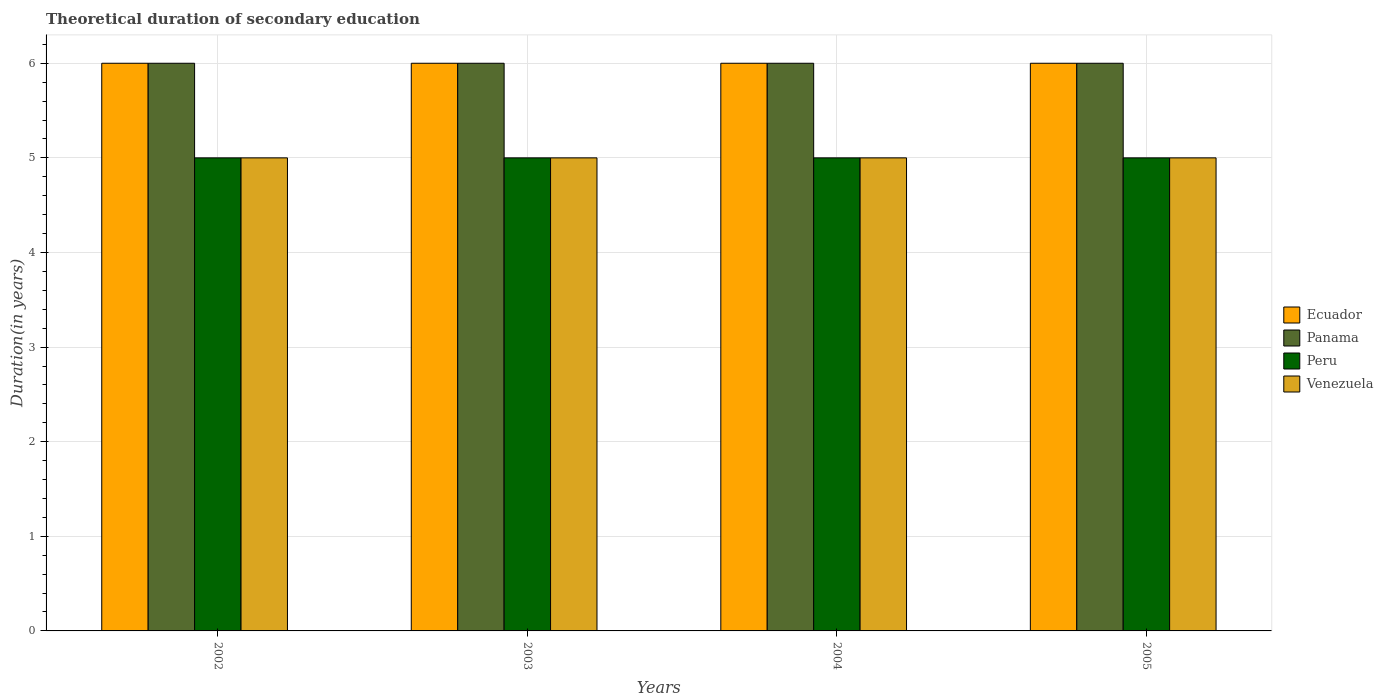How many different coloured bars are there?
Keep it short and to the point. 4. How many groups of bars are there?
Offer a very short reply. 4. How many bars are there on the 2nd tick from the right?
Your response must be concise. 4. In how many cases, is the number of bars for a given year not equal to the number of legend labels?
Your answer should be compact. 0. What is the total theoretical duration of secondary education in Peru in 2003?
Your response must be concise. 5. Across all years, what is the maximum total theoretical duration of secondary education in Ecuador?
Provide a short and direct response. 6. Across all years, what is the minimum total theoretical duration of secondary education in Ecuador?
Keep it short and to the point. 6. In which year was the total theoretical duration of secondary education in Venezuela maximum?
Offer a very short reply. 2002. In which year was the total theoretical duration of secondary education in Peru minimum?
Your response must be concise. 2002. What is the total total theoretical duration of secondary education in Peru in the graph?
Make the answer very short. 20. In the year 2005, what is the difference between the total theoretical duration of secondary education in Peru and total theoretical duration of secondary education in Ecuador?
Offer a very short reply. -1. In how many years, is the total theoretical duration of secondary education in Panama greater than 4.2 years?
Offer a terse response. 4. What is the difference between the highest and the lowest total theoretical duration of secondary education in Venezuela?
Provide a succinct answer. 0. Is the sum of the total theoretical duration of secondary education in Peru in 2002 and 2005 greater than the maximum total theoretical duration of secondary education in Venezuela across all years?
Offer a terse response. Yes. Is it the case that in every year, the sum of the total theoretical duration of secondary education in Panama and total theoretical duration of secondary education in Venezuela is greater than the sum of total theoretical duration of secondary education in Peru and total theoretical duration of secondary education in Ecuador?
Your response must be concise. No. What does the 1st bar from the left in 2005 represents?
Provide a short and direct response. Ecuador. What does the 3rd bar from the right in 2002 represents?
Keep it short and to the point. Panama. Is it the case that in every year, the sum of the total theoretical duration of secondary education in Peru and total theoretical duration of secondary education in Panama is greater than the total theoretical duration of secondary education in Ecuador?
Your response must be concise. Yes. How many bars are there?
Ensure brevity in your answer.  16. Are all the bars in the graph horizontal?
Your answer should be compact. No. How many years are there in the graph?
Make the answer very short. 4. What is the difference between two consecutive major ticks on the Y-axis?
Your answer should be very brief. 1. Are the values on the major ticks of Y-axis written in scientific E-notation?
Ensure brevity in your answer.  No. How are the legend labels stacked?
Keep it short and to the point. Vertical. What is the title of the graph?
Give a very brief answer. Theoretical duration of secondary education. Does "Australia" appear as one of the legend labels in the graph?
Provide a short and direct response. No. What is the label or title of the X-axis?
Give a very brief answer. Years. What is the label or title of the Y-axis?
Your answer should be compact. Duration(in years). What is the Duration(in years) of Peru in 2002?
Your answer should be compact. 5. What is the Duration(in years) of Ecuador in 2003?
Provide a succinct answer. 6. What is the Duration(in years) in Panama in 2003?
Your answer should be very brief. 6. What is the Duration(in years) in Peru in 2003?
Your answer should be very brief. 5. What is the Duration(in years) in Peru in 2004?
Offer a terse response. 5. What is the Duration(in years) of Venezuela in 2004?
Your response must be concise. 5. What is the Duration(in years) in Peru in 2005?
Offer a very short reply. 5. What is the Duration(in years) in Venezuela in 2005?
Provide a short and direct response. 5. Across all years, what is the maximum Duration(in years) of Peru?
Make the answer very short. 5. Across all years, what is the maximum Duration(in years) of Venezuela?
Provide a succinct answer. 5. Across all years, what is the minimum Duration(in years) of Ecuador?
Provide a succinct answer. 6. Across all years, what is the minimum Duration(in years) of Panama?
Offer a very short reply. 6. Across all years, what is the minimum Duration(in years) of Peru?
Your answer should be very brief. 5. Across all years, what is the minimum Duration(in years) of Venezuela?
Your answer should be compact. 5. What is the difference between the Duration(in years) in Ecuador in 2002 and that in 2003?
Offer a terse response. 0. What is the difference between the Duration(in years) of Peru in 2002 and that in 2003?
Ensure brevity in your answer.  0. What is the difference between the Duration(in years) of Venezuela in 2002 and that in 2004?
Ensure brevity in your answer.  0. What is the difference between the Duration(in years) of Panama in 2002 and that in 2005?
Your response must be concise. 0. What is the difference between the Duration(in years) in Peru in 2002 and that in 2005?
Give a very brief answer. 0. What is the difference between the Duration(in years) of Peru in 2003 and that in 2004?
Keep it short and to the point. 0. What is the difference between the Duration(in years) of Panama in 2003 and that in 2005?
Offer a terse response. 0. What is the difference between the Duration(in years) in Peru in 2003 and that in 2005?
Give a very brief answer. 0. What is the difference between the Duration(in years) in Panama in 2004 and that in 2005?
Give a very brief answer. 0. What is the difference between the Duration(in years) in Venezuela in 2004 and that in 2005?
Make the answer very short. 0. What is the difference between the Duration(in years) of Ecuador in 2002 and the Duration(in years) of Panama in 2003?
Provide a succinct answer. 0. What is the difference between the Duration(in years) in Ecuador in 2002 and the Duration(in years) in Peru in 2003?
Your answer should be compact. 1. What is the difference between the Duration(in years) of Ecuador in 2002 and the Duration(in years) of Venezuela in 2003?
Provide a succinct answer. 1. What is the difference between the Duration(in years) of Panama in 2002 and the Duration(in years) of Peru in 2003?
Your answer should be very brief. 1. What is the difference between the Duration(in years) of Panama in 2002 and the Duration(in years) of Venezuela in 2003?
Your answer should be very brief. 1. What is the difference between the Duration(in years) of Peru in 2002 and the Duration(in years) of Venezuela in 2003?
Make the answer very short. 0. What is the difference between the Duration(in years) in Ecuador in 2002 and the Duration(in years) in Panama in 2004?
Your response must be concise. 0. What is the difference between the Duration(in years) in Ecuador in 2002 and the Duration(in years) in Peru in 2004?
Your answer should be compact. 1. What is the difference between the Duration(in years) in Panama in 2002 and the Duration(in years) in Peru in 2004?
Your answer should be very brief. 1. What is the difference between the Duration(in years) of Panama in 2002 and the Duration(in years) of Peru in 2005?
Your answer should be compact. 1. What is the difference between the Duration(in years) of Panama in 2002 and the Duration(in years) of Venezuela in 2005?
Offer a very short reply. 1. What is the difference between the Duration(in years) in Peru in 2002 and the Duration(in years) in Venezuela in 2005?
Keep it short and to the point. 0. What is the difference between the Duration(in years) of Ecuador in 2003 and the Duration(in years) of Panama in 2004?
Your answer should be compact. 0. What is the difference between the Duration(in years) in Ecuador in 2003 and the Duration(in years) in Peru in 2004?
Your answer should be very brief. 1. What is the difference between the Duration(in years) in Ecuador in 2003 and the Duration(in years) in Venezuela in 2004?
Offer a very short reply. 1. What is the difference between the Duration(in years) of Panama in 2003 and the Duration(in years) of Peru in 2004?
Provide a succinct answer. 1. What is the difference between the Duration(in years) of Ecuador in 2003 and the Duration(in years) of Peru in 2005?
Offer a terse response. 1. What is the difference between the Duration(in years) of Peru in 2003 and the Duration(in years) of Venezuela in 2005?
Give a very brief answer. 0. What is the difference between the Duration(in years) of Ecuador in 2004 and the Duration(in years) of Panama in 2005?
Your response must be concise. 0. What is the difference between the Duration(in years) in Ecuador in 2004 and the Duration(in years) in Venezuela in 2005?
Your answer should be very brief. 1. What is the difference between the Duration(in years) in Peru in 2004 and the Duration(in years) in Venezuela in 2005?
Offer a very short reply. 0. What is the average Duration(in years) of Ecuador per year?
Provide a succinct answer. 6. What is the average Duration(in years) of Peru per year?
Ensure brevity in your answer.  5. In the year 2002, what is the difference between the Duration(in years) of Ecuador and Duration(in years) of Peru?
Provide a short and direct response. 1. In the year 2002, what is the difference between the Duration(in years) in Panama and Duration(in years) in Peru?
Provide a short and direct response. 1. In the year 2003, what is the difference between the Duration(in years) in Ecuador and Duration(in years) in Panama?
Give a very brief answer. 0. In the year 2003, what is the difference between the Duration(in years) in Ecuador and Duration(in years) in Peru?
Offer a very short reply. 1. In the year 2003, what is the difference between the Duration(in years) in Peru and Duration(in years) in Venezuela?
Keep it short and to the point. 0. In the year 2004, what is the difference between the Duration(in years) in Panama and Duration(in years) in Peru?
Keep it short and to the point. 1. In the year 2004, what is the difference between the Duration(in years) in Panama and Duration(in years) in Venezuela?
Your answer should be very brief. 1. In the year 2004, what is the difference between the Duration(in years) of Peru and Duration(in years) of Venezuela?
Provide a short and direct response. 0. In the year 2005, what is the difference between the Duration(in years) in Ecuador and Duration(in years) in Peru?
Provide a succinct answer. 1. In the year 2005, what is the difference between the Duration(in years) in Peru and Duration(in years) in Venezuela?
Your answer should be very brief. 0. What is the ratio of the Duration(in years) in Ecuador in 2002 to that in 2003?
Your answer should be compact. 1. What is the ratio of the Duration(in years) in Panama in 2002 to that in 2003?
Offer a very short reply. 1. What is the ratio of the Duration(in years) in Peru in 2002 to that in 2003?
Make the answer very short. 1. What is the ratio of the Duration(in years) in Venezuela in 2002 to that in 2003?
Provide a succinct answer. 1. What is the ratio of the Duration(in years) of Ecuador in 2002 to that in 2005?
Keep it short and to the point. 1. What is the ratio of the Duration(in years) in Peru in 2002 to that in 2005?
Ensure brevity in your answer.  1. What is the ratio of the Duration(in years) in Panama in 2003 to that in 2004?
Provide a succinct answer. 1. What is the ratio of the Duration(in years) of Panama in 2003 to that in 2005?
Your response must be concise. 1. What is the ratio of the Duration(in years) in Venezuela in 2003 to that in 2005?
Offer a terse response. 1. What is the ratio of the Duration(in years) in Ecuador in 2004 to that in 2005?
Give a very brief answer. 1. What is the ratio of the Duration(in years) of Venezuela in 2004 to that in 2005?
Provide a short and direct response. 1. What is the difference between the highest and the lowest Duration(in years) in Ecuador?
Ensure brevity in your answer.  0. What is the difference between the highest and the lowest Duration(in years) of Peru?
Offer a very short reply. 0. 